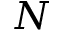Convert formula to latex. <formula><loc_0><loc_0><loc_500><loc_500>N</formula> 